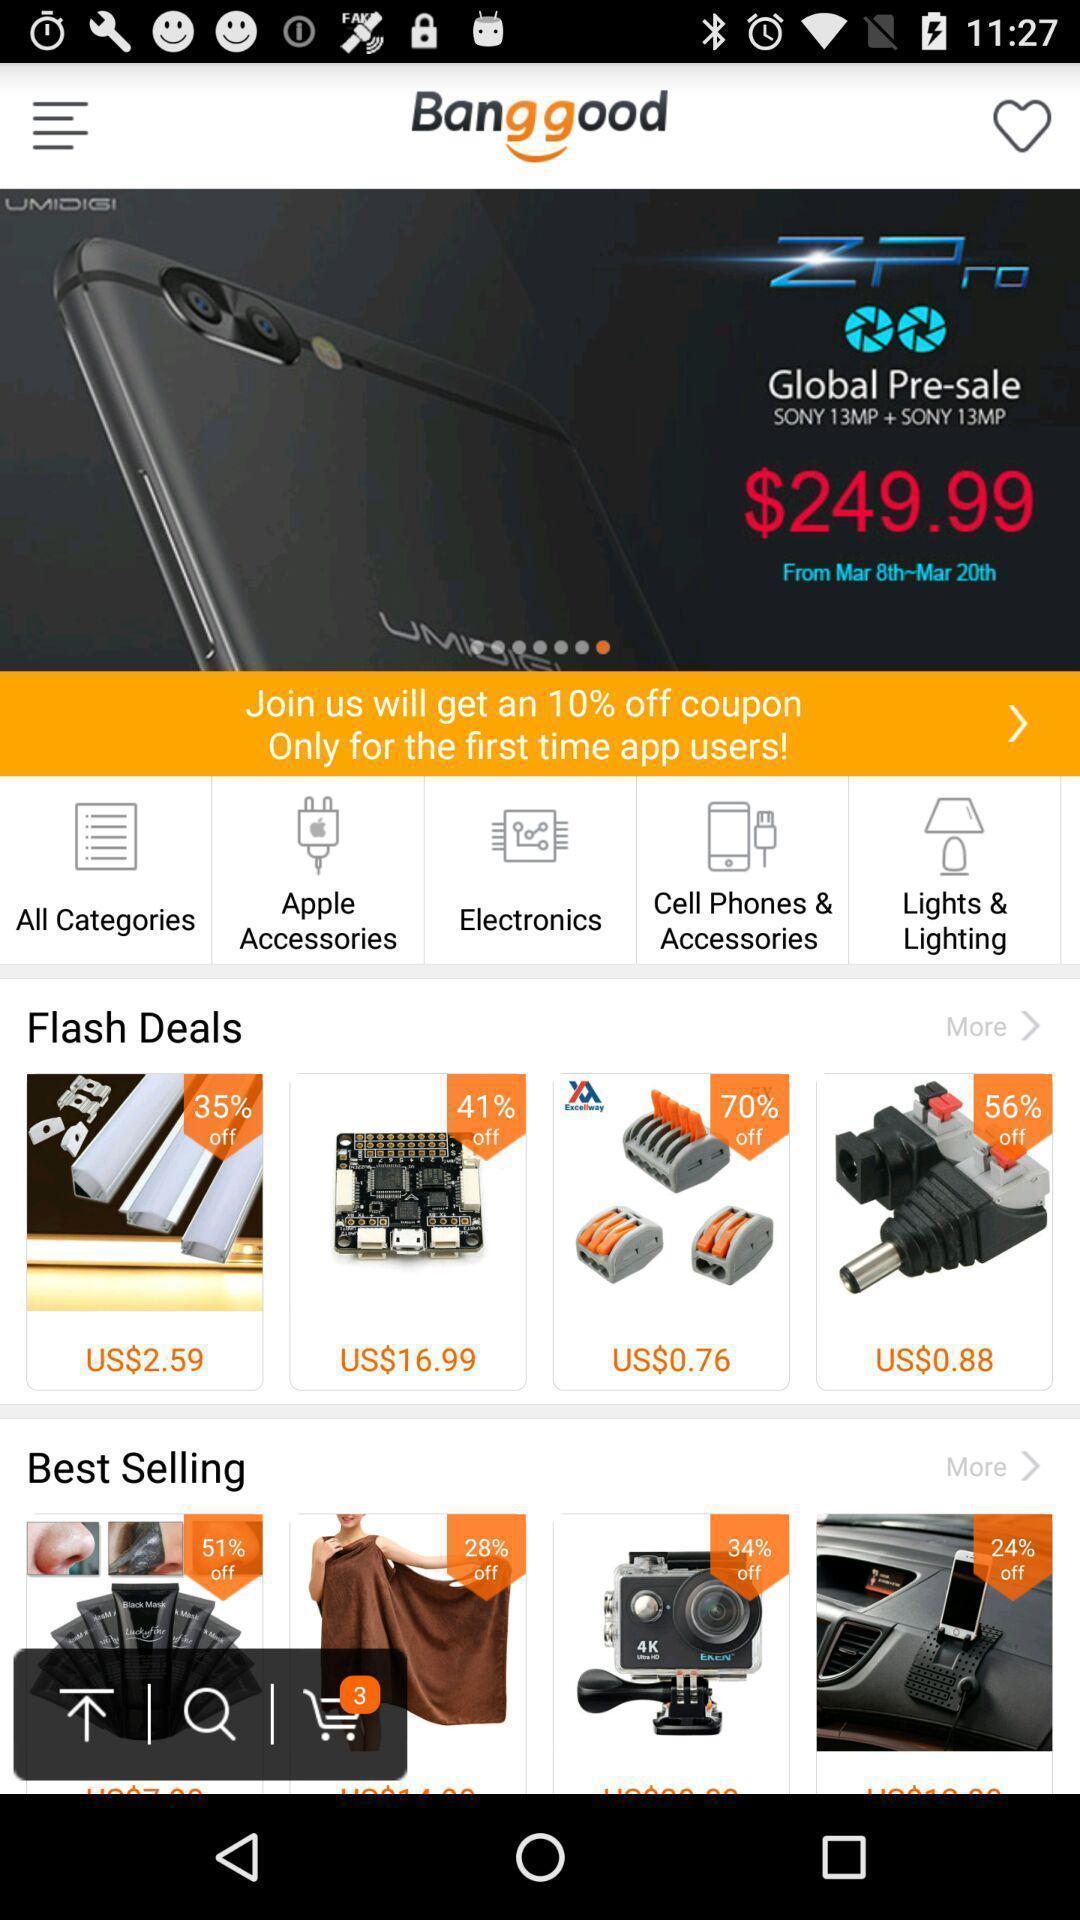What can you discern from this picture? Welcome page of a shopping app. 